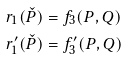Convert formula to latex. <formula><loc_0><loc_0><loc_500><loc_500>r _ { 1 } ( \check { P } ) & = f _ { 3 } ( P , Q ) \\ r ^ { \prime } _ { 1 } ( \check { P } ) & = f ^ { \prime } _ { 3 } ( P , Q )</formula> 